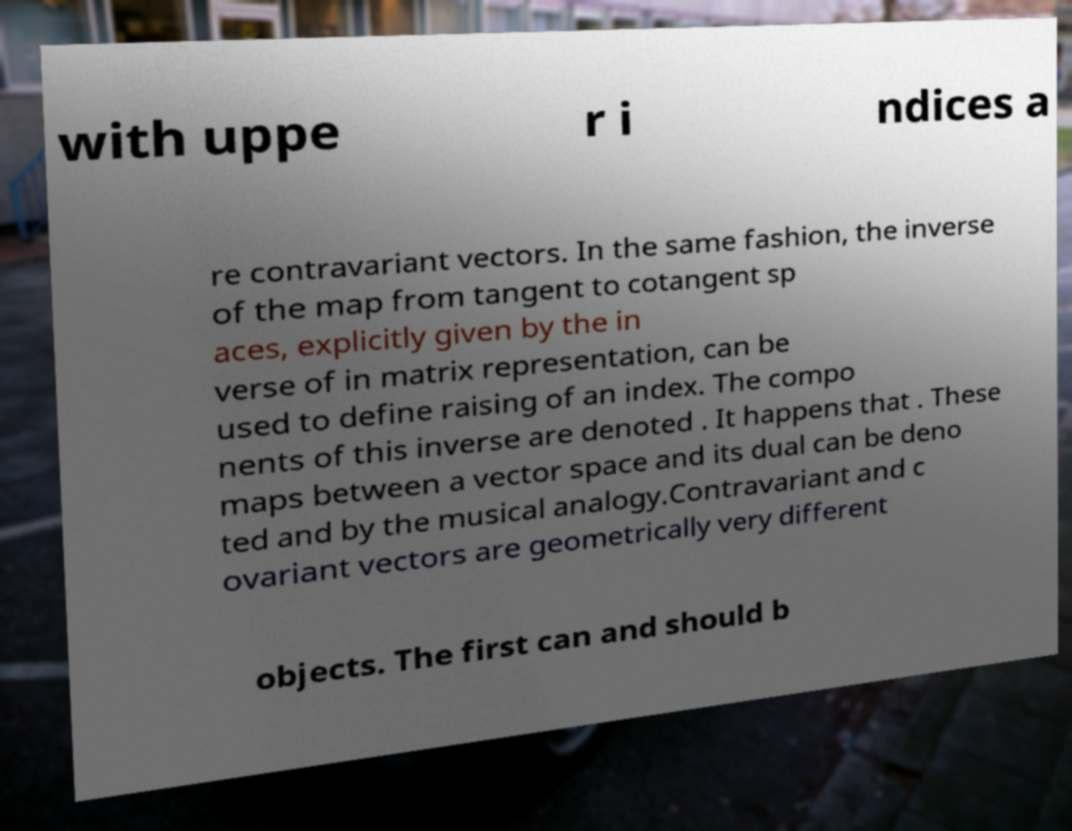Can you accurately transcribe the text from the provided image for me? with uppe r i ndices a re contravariant vectors. In the same fashion, the inverse of the map from tangent to cotangent sp aces, explicitly given by the in verse of in matrix representation, can be used to define raising of an index. The compo nents of this inverse are denoted . It happens that . These maps between a vector space and its dual can be deno ted and by the musical analogy.Contravariant and c ovariant vectors are geometrically very different objects. The first can and should b 